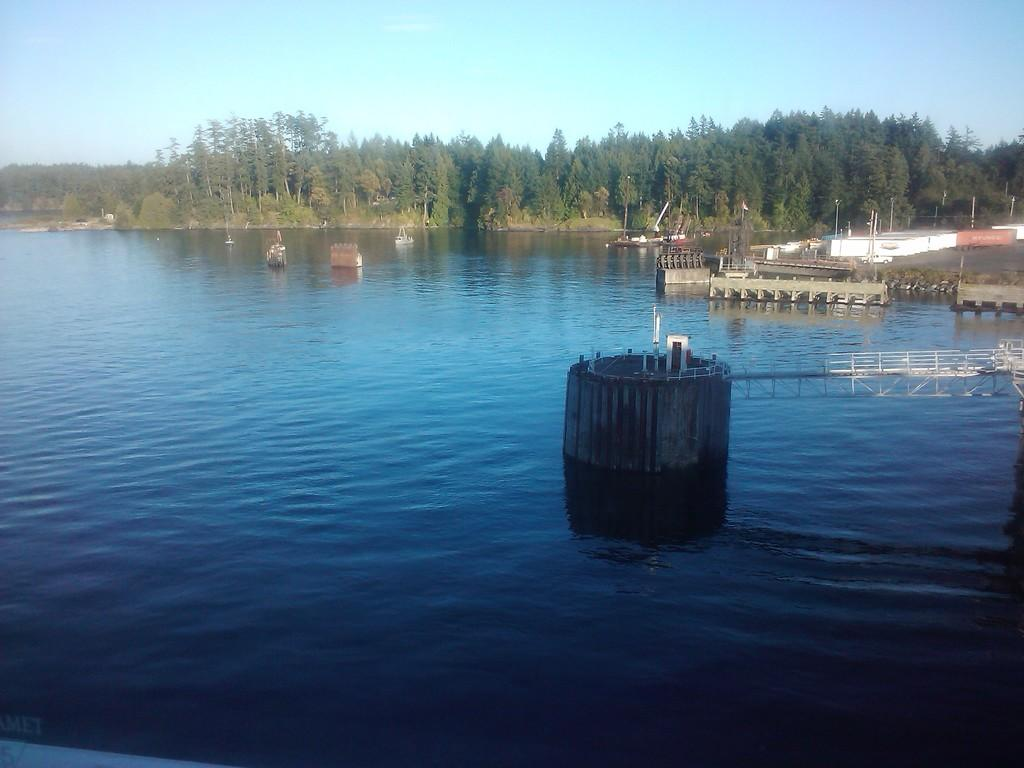What is in the water in the image? There are boats in the water in the image. What can be seen to the right of the boats? There are containers to the right in the image. What type of natural environment is visible in the background? There are many trees in the background of the image. What is visible above the trees and containers? The sky is visible in the background of the image. How many apples are hanging from the trees in the image? There are no apples visible in the image; only trees are present in the background. 